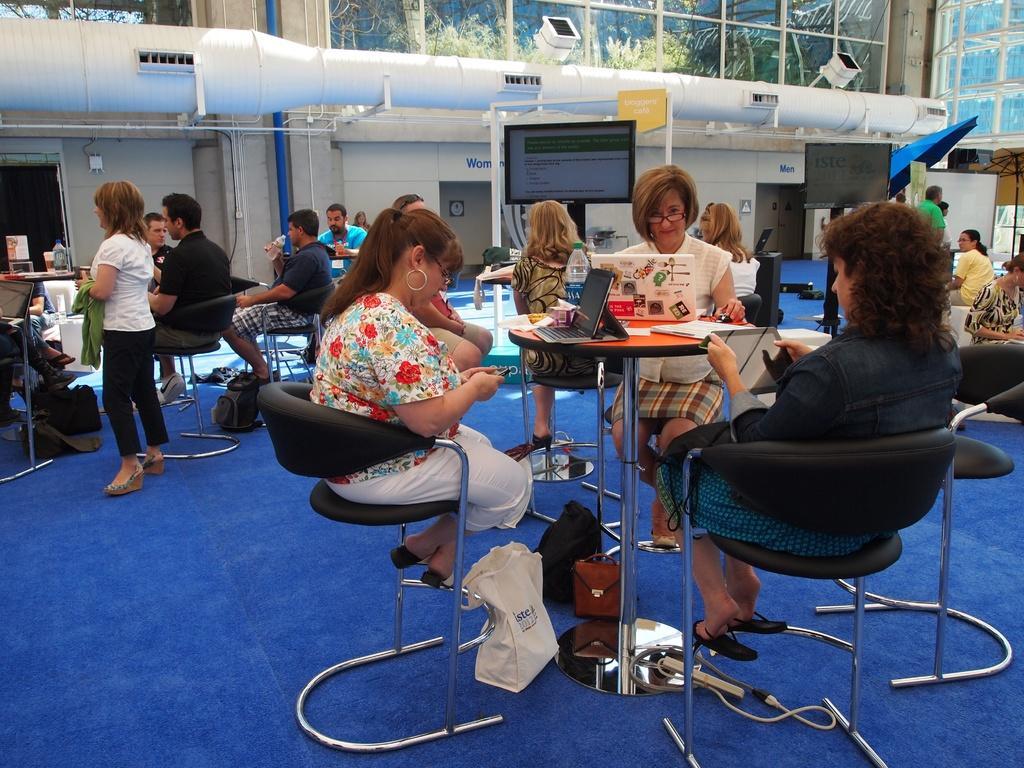In one or two sentences, can you explain what this image depicts? In this Image I see number of people in which most of them are sitting on chairs and rest of them are standing, I can also see there are tables in front of them on which there are few things. In the background I see few screens and the wall. 